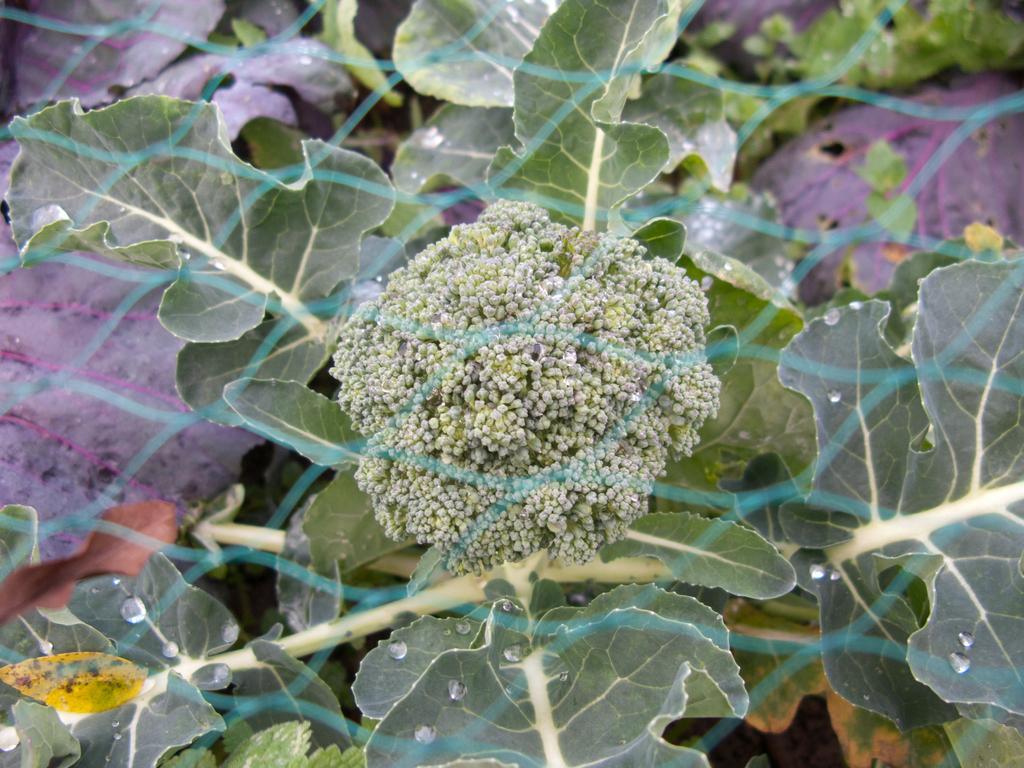Describe this image in one or two sentences. In this image there is a plant in the front and there are leaves. 